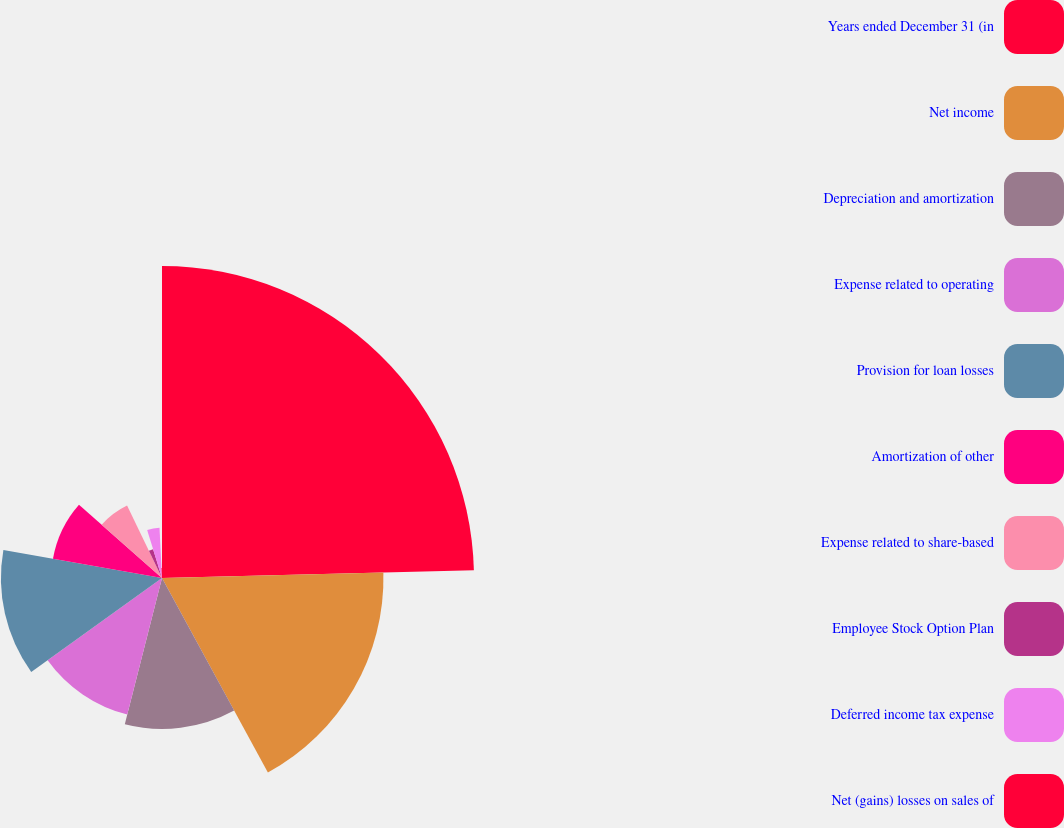Convert chart to OTSL. <chart><loc_0><loc_0><loc_500><loc_500><pie_chart><fcel>Years ended December 31 (in<fcel>Net income<fcel>Depreciation and amortization<fcel>Expense related to operating<fcel>Provision for loan losses<fcel>Amortization of other<fcel>Expense related to share-based<fcel>Employee Stock Option Plan<fcel>Deferred income tax expense<fcel>Net (gains) losses on sales of<nl><fcel>24.6%<fcel>17.46%<fcel>11.9%<fcel>11.11%<fcel>12.7%<fcel>8.73%<fcel>6.35%<fcel>2.38%<fcel>3.97%<fcel>0.79%<nl></chart> 